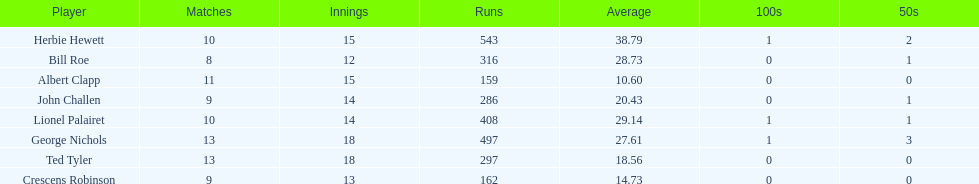Which players played in 10 or fewer matches? Herbie Hewett, Lionel Palairet, Bill Roe, John Challen, Crescens Robinson. Of these, which played in only 12 innings? Bill Roe. 